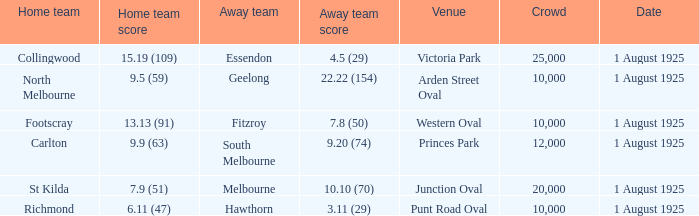When did the match take place that had a home team score of 7.9 (51)? 1 August 1925. 